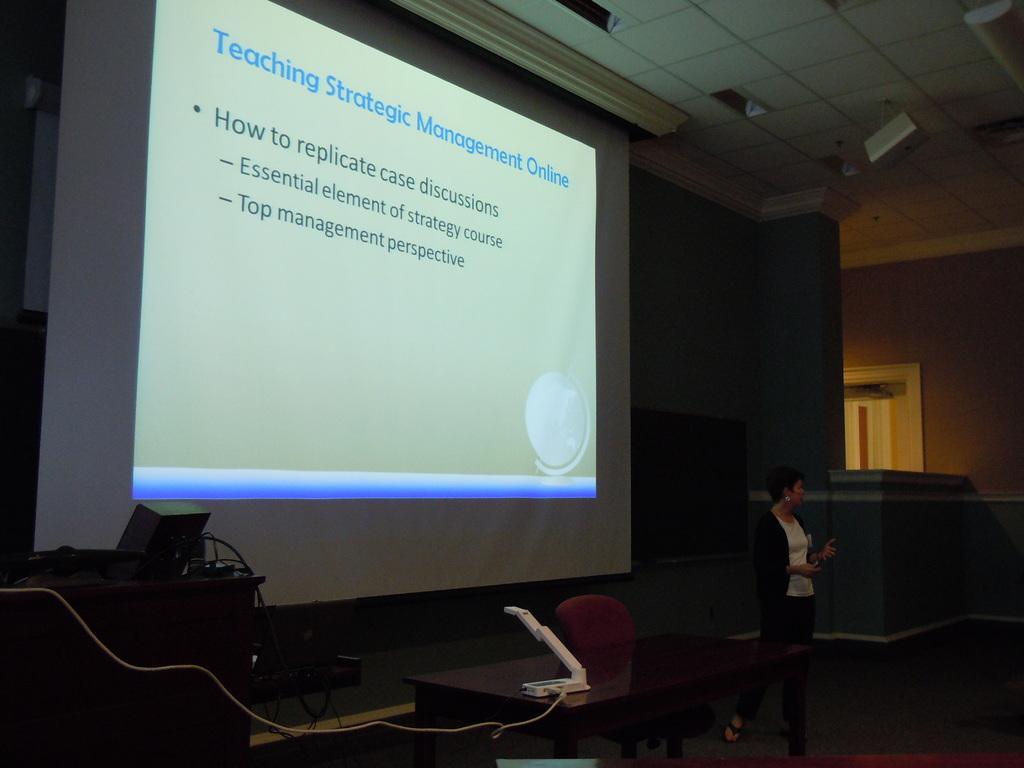Can you describe this image briefly? In the center of the image there is a table and a chair. There is a lady standing behind a table she is presenting a presentation. In the background there is a screen. 